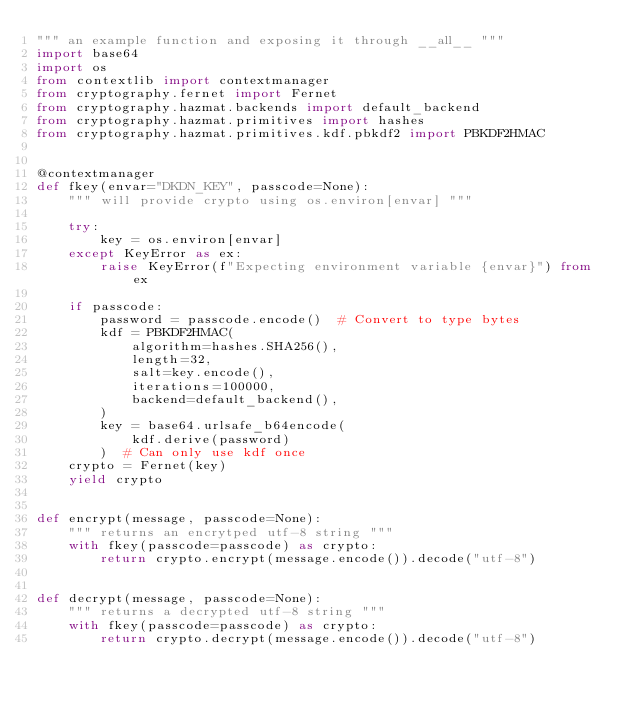Convert code to text. <code><loc_0><loc_0><loc_500><loc_500><_Python_>""" an example function and exposing it through __all__ """
import base64
import os
from contextlib import contextmanager
from cryptography.fernet import Fernet
from cryptography.hazmat.backends import default_backend
from cryptography.hazmat.primitives import hashes
from cryptography.hazmat.primitives.kdf.pbkdf2 import PBKDF2HMAC


@contextmanager
def fkey(envar="DKDN_KEY", passcode=None):
    """ will provide crypto using os.environ[envar] """

    try:
        key = os.environ[envar]
    except KeyError as ex:
        raise KeyError(f"Expecting environment variable {envar}") from ex

    if passcode:
        password = passcode.encode()  # Convert to type bytes
        kdf = PBKDF2HMAC(
            algorithm=hashes.SHA256(),
            length=32,
            salt=key.encode(),
            iterations=100000,
            backend=default_backend(),
        )
        key = base64.urlsafe_b64encode(
            kdf.derive(password)
        )  # Can only use kdf once
    crypto = Fernet(key)
    yield crypto


def encrypt(message, passcode=None):
    """ returns an encrytped utf-8 string """
    with fkey(passcode=passcode) as crypto:
        return crypto.encrypt(message.encode()).decode("utf-8")


def decrypt(message, passcode=None):
    """ returns a decrypted utf-8 string """
    with fkey(passcode=passcode) as crypto:
        return crypto.decrypt(message.encode()).decode("utf-8")
</code> 